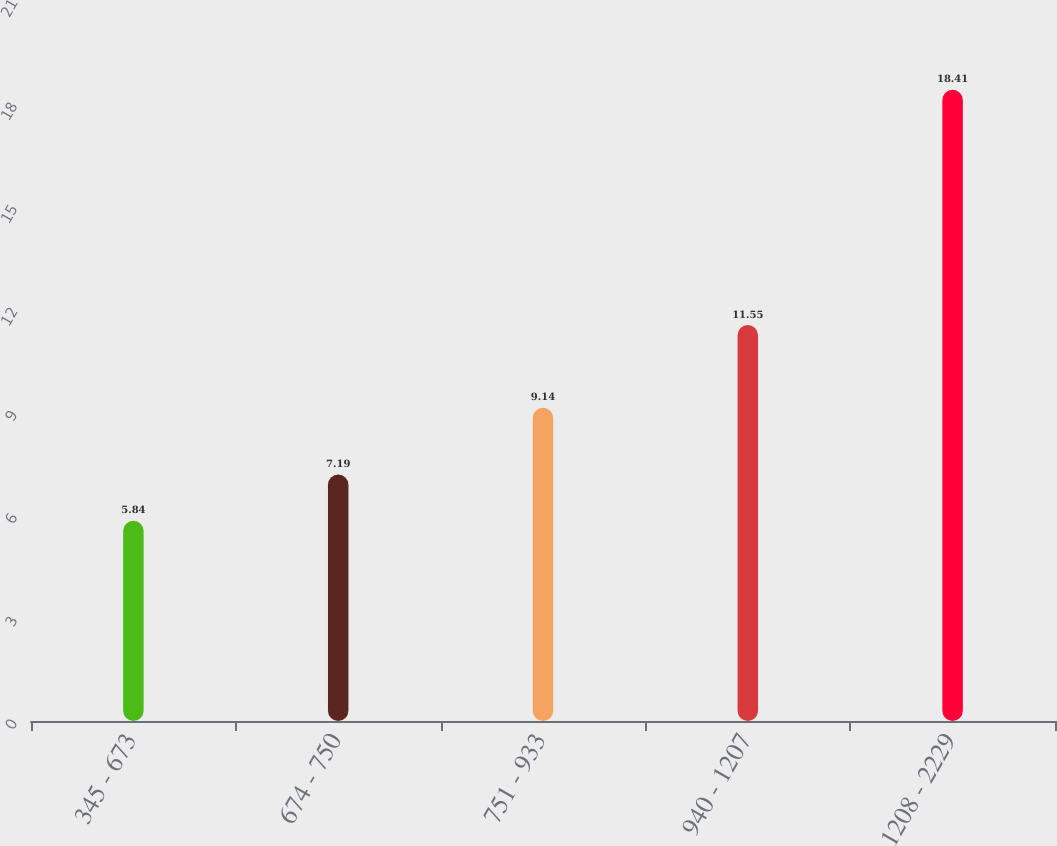<chart> <loc_0><loc_0><loc_500><loc_500><bar_chart><fcel>345 - 673<fcel>674 - 750<fcel>751 - 933<fcel>940 - 1207<fcel>1208 - 2229<nl><fcel>5.84<fcel>7.19<fcel>9.14<fcel>11.55<fcel>18.41<nl></chart> 